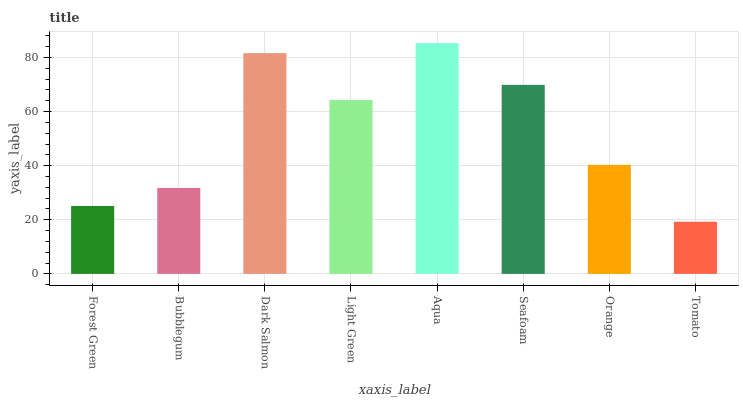Is Tomato the minimum?
Answer yes or no. Yes. Is Aqua the maximum?
Answer yes or no. Yes. Is Bubblegum the minimum?
Answer yes or no. No. Is Bubblegum the maximum?
Answer yes or no. No. Is Bubblegum greater than Forest Green?
Answer yes or no. Yes. Is Forest Green less than Bubblegum?
Answer yes or no. Yes. Is Forest Green greater than Bubblegum?
Answer yes or no. No. Is Bubblegum less than Forest Green?
Answer yes or no. No. Is Light Green the high median?
Answer yes or no. Yes. Is Orange the low median?
Answer yes or no. Yes. Is Seafoam the high median?
Answer yes or no. No. Is Seafoam the low median?
Answer yes or no. No. 